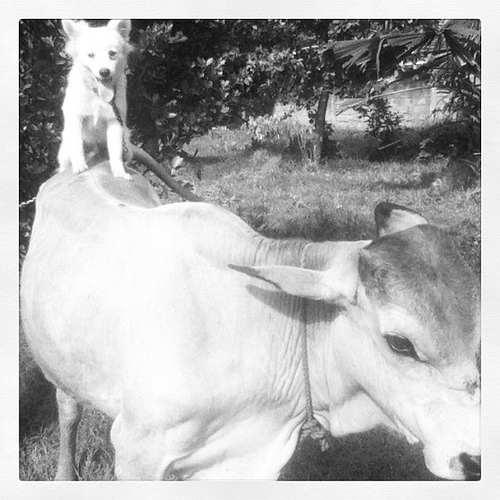How many dogs are in the picture? 1 